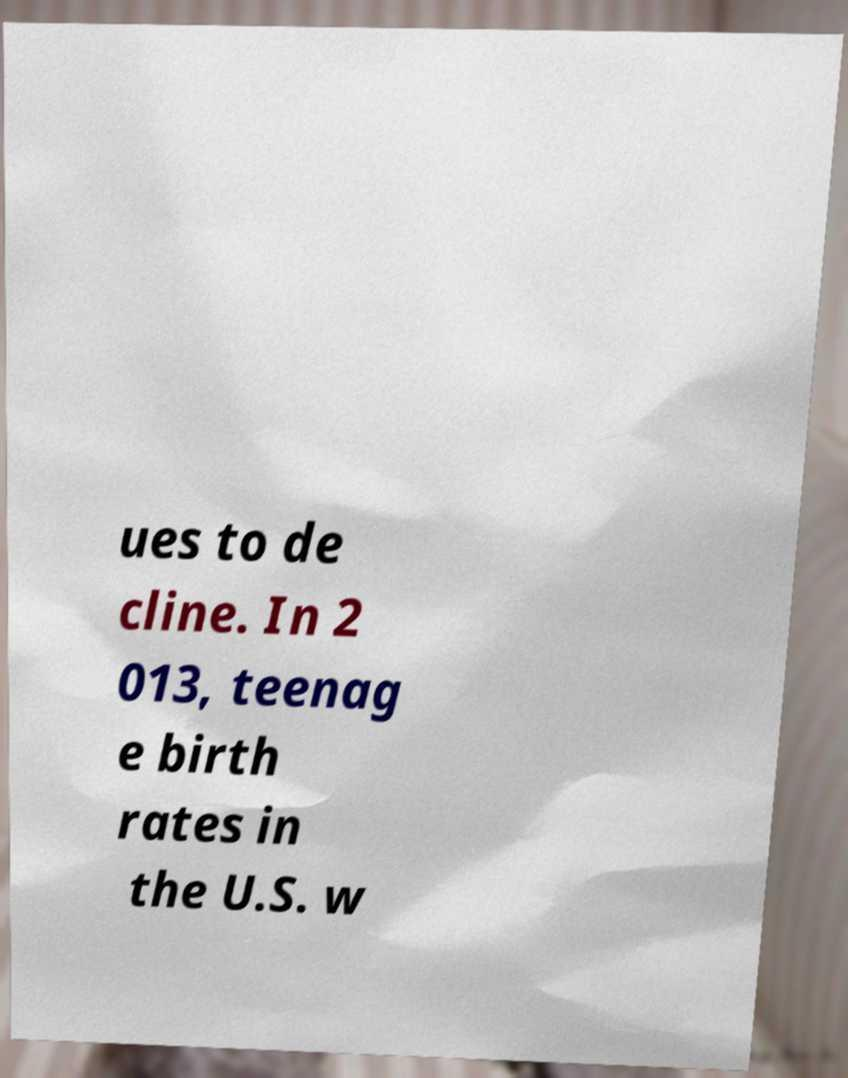For documentation purposes, I need the text within this image transcribed. Could you provide that? ues to de cline. In 2 013, teenag e birth rates in the U.S. w 